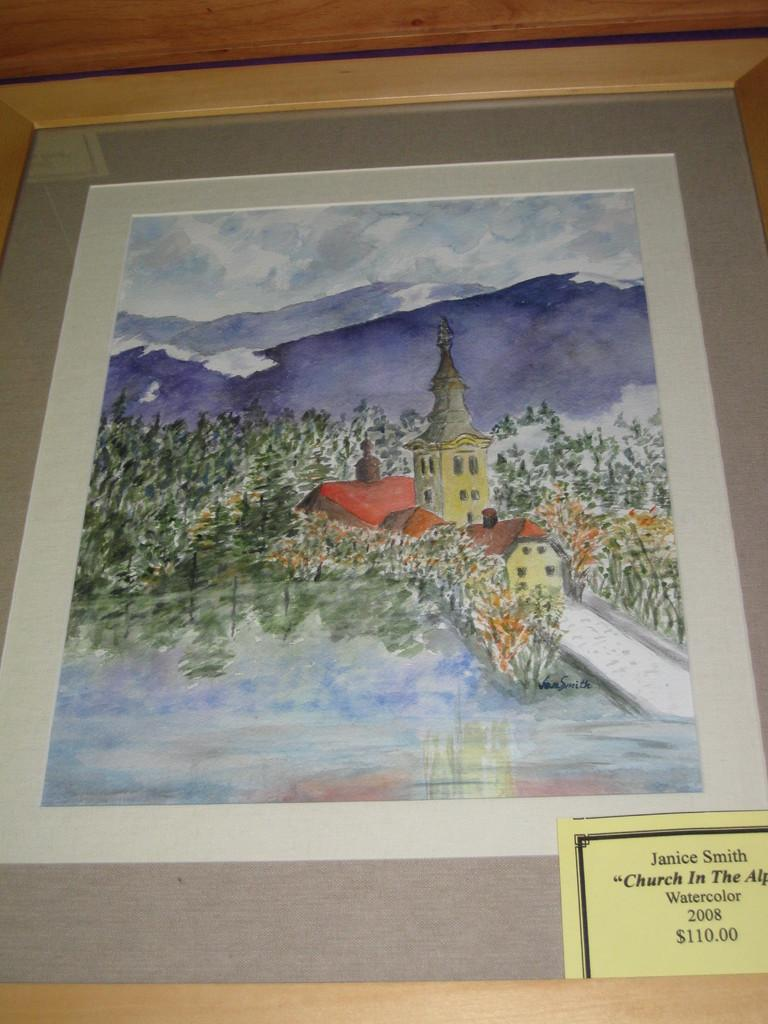<image>
Render a clear and concise summary of the photo. A watercolor painting by Janice Smith was created in 2008. 